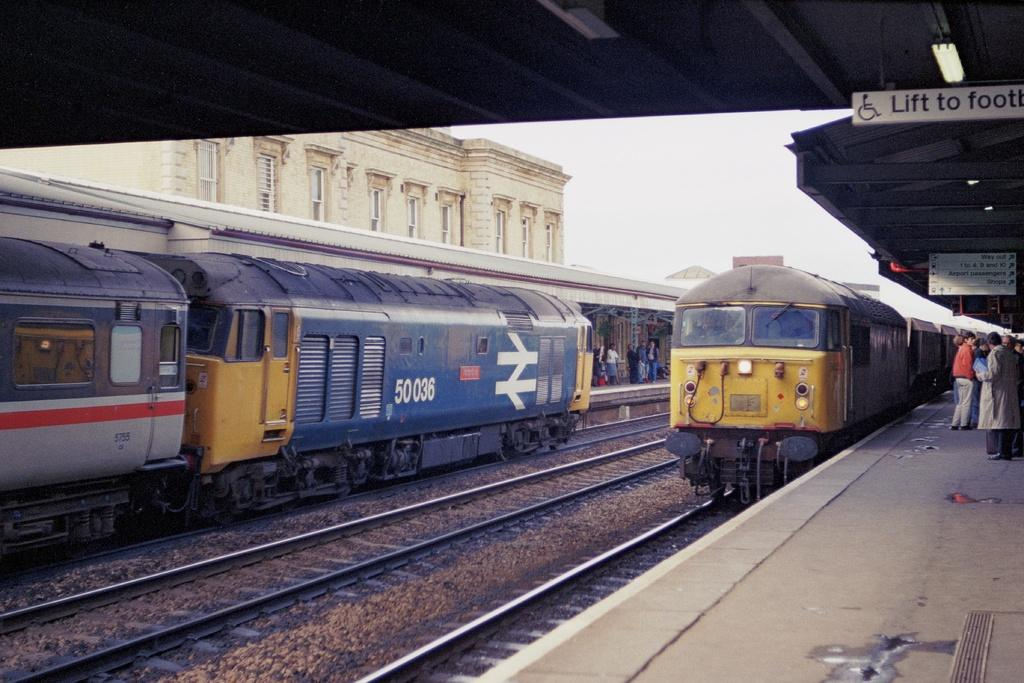<image>
Create a compact narrative representing the image presented. A passenger train with 50036 on it pulls out of a station. 